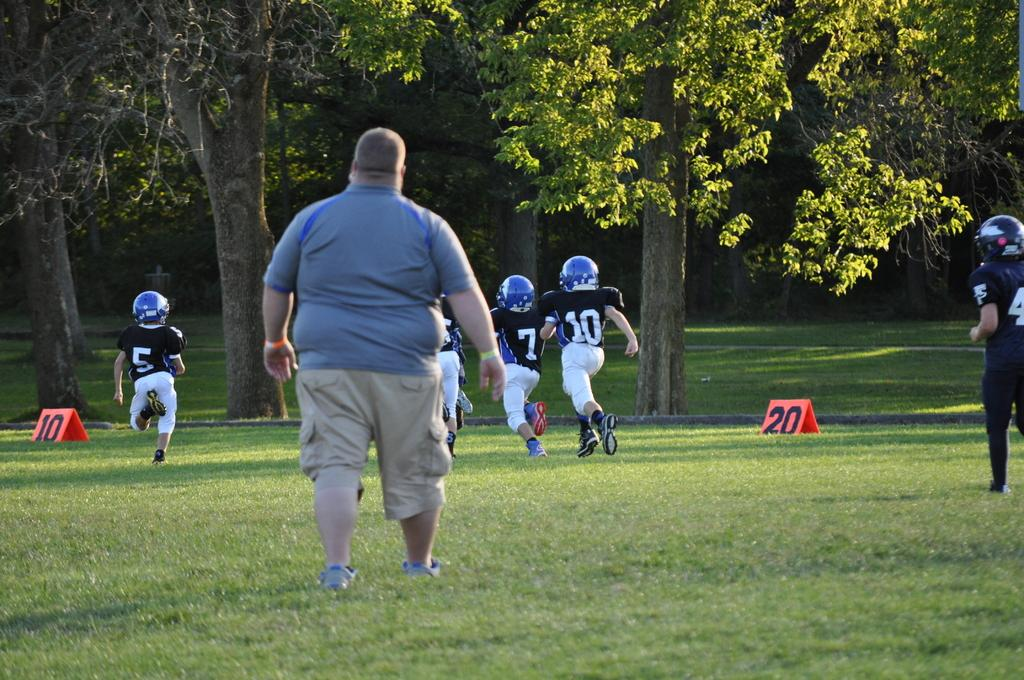How many people are in the image? There are people in the image, but the exact number is not specified. What can be observed about the people's clothing? The people are wearing different color dresses. What can be seen in the background of the image? There are trees visible in the background. What is the color of the object on the ground? There is a red color board on the ground. How many cars are parked near the people in the image? There is no mention of cars in the image, so we cannot determine the number of parked cars. What type of cup is being used by the people in the image? There is no cup visible in the image. 